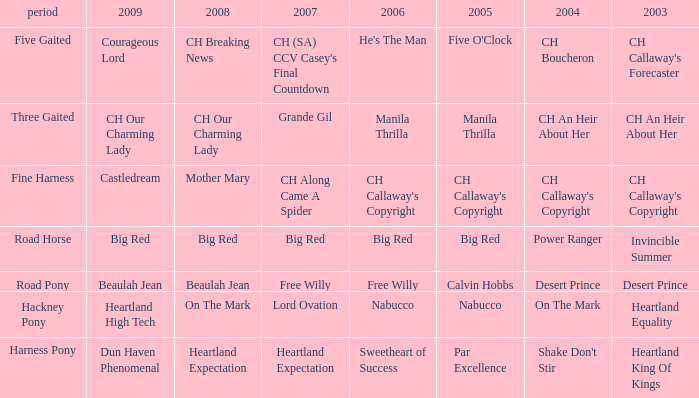What year does the 2007 big crimson belong to? Road Horse. 